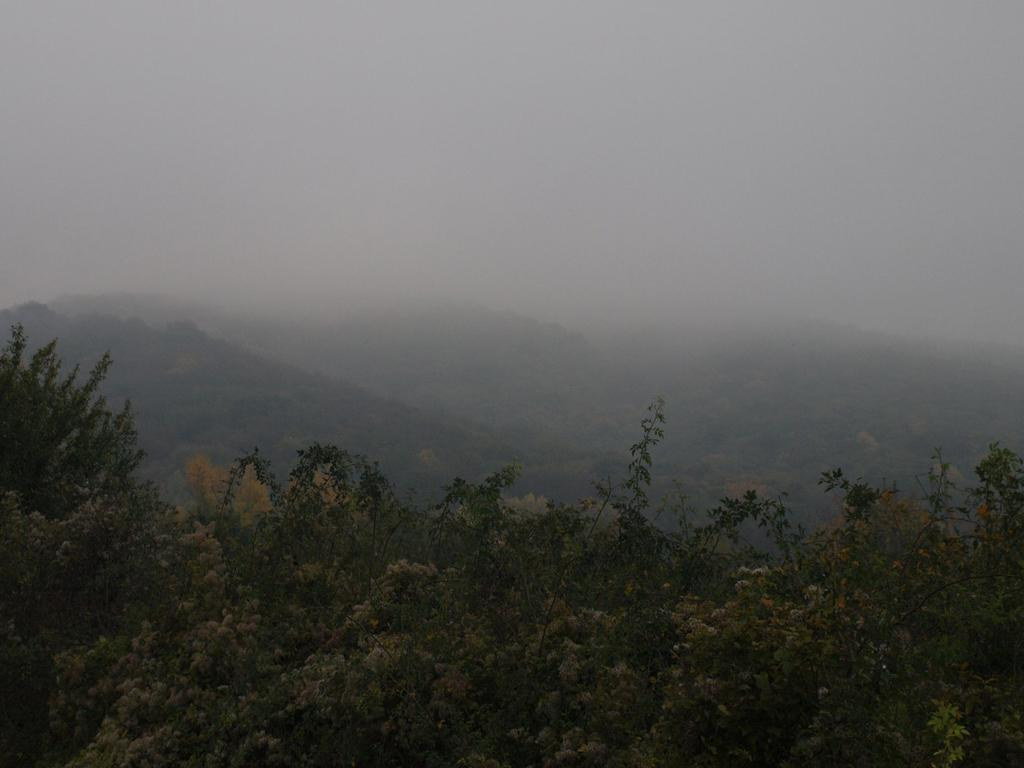What type of vegetation or plants can be seen at the bottom of the image? There is greenery at the bottom side of the image. What is present in the center of the image? There is smoke in the center of the image. Where is the camera located in the image? There is no camera present in the image. What type of quilt is being used to cover the smoke in the image? There is no quilt present in the image, and the smoke is not being covered. 